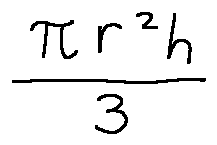Convert formula to latex. <formula><loc_0><loc_0><loc_500><loc_500>\frac { \pi r ^ { 2 } h } { 3 }</formula> 